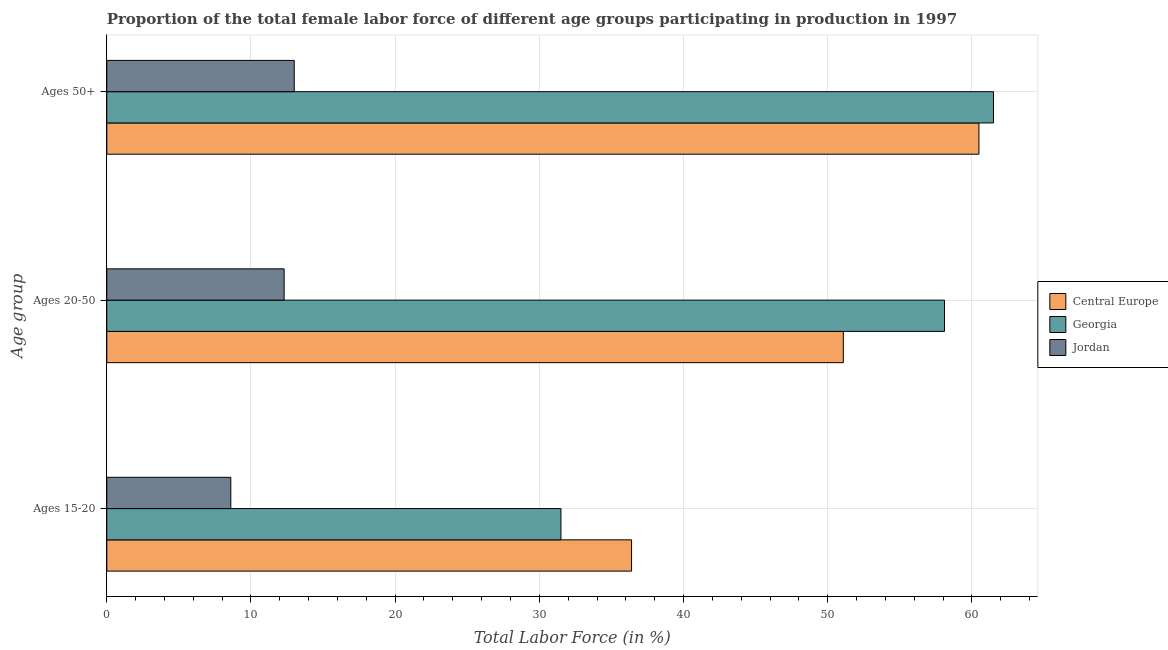How many different coloured bars are there?
Provide a succinct answer. 3. Are the number of bars per tick equal to the number of legend labels?
Make the answer very short. Yes. Are the number of bars on each tick of the Y-axis equal?
Provide a succinct answer. Yes. How many bars are there on the 1st tick from the top?
Your answer should be compact. 3. What is the label of the 2nd group of bars from the top?
Make the answer very short. Ages 20-50. What is the percentage of female labor force within the age group 20-50 in Jordan?
Give a very brief answer. 12.3. Across all countries, what is the maximum percentage of female labor force above age 50?
Ensure brevity in your answer.  61.5. Across all countries, what is the minimum percentage of female labor force within the age group 20-50?
Make the answer very short. 12.3. In which country was the percentage of female labor force within the age group 15-20 maximum?
Provide a short and direct response. Central Europe. In which country was the percentage of female labor force within the age group 15-20 minimum?
Your answer should be very brief. Jordan. What is the total percentage of female labor force above age 50 in the graph?
Your response must be concise. 134.99. What is the difference between the percentage of female labor force within the age group 15-20 in Georgia and that in Jordan?
Your response must be concise. 22.9. What is the difference between the percentage of female labor force within the age group 20-50 in Georgia and the percentage of female labor force within the age group 15-20 in Jordan?
Keep it short and to the point. 49.5. What is the average percentage of female labor force within the age group 20-50 per country?
Provide a succinct answer. 40.5. What is the difference between the percentage of female labor force above age 50 and percentage of female labor force within the age group 20-50 in Jordan?
Provide a short and direct response. 0.7. What is the ratio of the percentage of female labor force within the age group 20-50 in Jordan to that in Georgia?
Your response must be concise. 0.21. Is the percentage of female labor force within the age group 15-20 in Jordan less than that in Georgia?
Your answer should be very brief. Yes. What is the difference between the highest and the second highest percentage of female labor force above age 50?
Provide a succinct answer. 1.01. What is the difference between the highest and the lowest percentage of female labor force within the age group 20-50?
Make the answer very short. 45.8. Is the sum of the percentage of female labor force above age 50 in Jordan and Central Europe greater than the maximum percentage of female labor force within the age group 15-20 across all countries?
Make the answer very short. Yes. What does the 1st bar from the top in Ages 50+ represents?
Make the answer very short. Jordan. What does the 2nd bar from the bottom in Ages 50+ represents?
Provide a short and direct response. Georgia. Is it the case that in every country, the sum of the percentage of female labor force within the age group 15-20 and percentage of female labor force within the age group 20-50 is greater than the percentage of female labor force above age 50?
Provide a short and direct response. Yes. How many bars are there?
Offer a terse response. 9. Does the graph contain any zero values?
Make the answer very short. No. Where does the legend appear in the graph?
Make the answer very short. Center right. How many legend labels are there?
Offer a very short reply. 3. What is the title of the graph?
Make the answer very short. Proportion of the total female labor force of different age groups participating in production in 1997. Does "St. Kitts and Nevis" appear as one of the legend labels in the graph?
Offer a very short reply. No. What is the label or title of the Y-axis?
Ensure brevity in your answer.  Age group. What is the Total Labor Force (in %) in Central Europe in Ages 15-20?
Your answer should be compact. 36.4. What is the Total Labor Force (in %) of Georgia in Ages 15-20?
Your answer should be very brief. 31.5. What is the Total Labor Force (in %) of Jordan in Ages 15-20?
Your response must be concise. 8.6. What is the Total Labor Force (in %) in Central Europe in Ages 20-50?
Offer a terse response. 51.09. What is the Total Labor Force (in %) of Georgia in Ages 20-50?
Your answer should be compact. 58.1. What is the Total Labor Force (in %) of Jordan in Ages 20-50?
Keep it short and to the point. 12.3. What is the Total Labor Force (in %) in Central Europe in Ages 50+?
Provide a short and direct response. 60.49. What is the Total Labor Force (in %) of Georgia in Ages 50+?
Your answer should be very brief. 61.5. Across all Age group, what is the maximum Total Labor Force (in %) of Central Europe?
Ensure brevity in your answer.  60.49. Across all Age group, what is the maximum Total Labor Force (in %) in Georgia?
Offer a very short reply. 61.5. Across all Age group, what is the minimum Total Labor Force (in %) of Central Europe?
Your response must be concise. 36.4. Across all Age group, what is the minimum Total Labor Force (in %) in Georgia?
Offer a terse response. 31.5. Across all Age group, what is the minimum Total Labor Force (in %) of Jordan?
Keep it short and to the point. 8.6. What is the total Total Labor Force (in %) of Central Europe in the graph?
Ensure brevity in your answer.  147.97. What is the total Total Labor Force (in %) in Georgia in the graph?
Keep it short and to the point. 151.1. What is the total Total Labor Force (in %) in Jordan in the graph?
Give a very brief answer. 33.9. What is the difference between the Total Labor Force (in %) in Central Europe in Ages 15-20 and that in Ages 20-50?
Your answer should be very brief. -14.69. What is the difference between the Total Labor Force (in %) of Georgia in Ages 15-20 and that in Ages 20-50?
Offer a terse response. -26.6. What is the difference between the Total Labor Force (in %) of Jordan in Ages 15-20 and that in Ages 20-50?
Provide a succinct answer. -3.7. What is the difference between the Total Labor Force (in %) of Central Europe in Ages 15-20 and that in Ages 50+?
Ensure brevity in your answer.  -24.09. What is the difference between the Total Labor Force (in %) in Georgia in Ages 15-20 and that in Ages 50+?
Your answer should be very brief. -30. What is the difference between the Total Labor Force (in %) in Jordan in Ages 15-20 and that in Ages 50+?
Keep it short and to the point. -4.4. What is the difference between the Total Labor Force (in %) of Central Europe in Ages 20-50 and that in Ages 50+?
Ensure brevity in your answer.  -9.41. What is the difference between the Total Labor Force (in %) in Georgia in Ages 20-50 and that in Ages 50+?
Make the answer very short. -3.4. What is the difference between the Total Labor Force (in %) in Central Europe in Ages 15-20 and the Total Labor Force (in %) in Georgia in Ages 20-50?
Keep it short and to the point. -21.7. What is the difference between the Total Labor Force (in %) in Central Europe in Ages 15-20 and the Total Labor Force (in %) in Jordan in Ages 20-50?
Keep it short and to the point. 24.1. What is the difference between the Total Labor Force (in %) of Georgia in Ages 15-20 and the Total Labor Force (in %) of Jordan in Ages 20-50?
Your answer should be very brief. 19.2. What is the difference between the Total Labor Force (in %) in Central Europe in Ages 15-20 and the Total Labor Force (in %) in Georgia in Ages 50+?
Offer a terse response. -25.1. What is the difference between the Total Labor Force (in %) of Central Europe in Ages 15-20 and the Total Labor Force (in %) of Jordan in Ages 50+?
Make the answer very short. 23.4. What is the difference between the Total Labor Force (in %) of Central Europe in Ages 20-50 and the Total Labor Force (in %) of Georgia in Ages 50+?
Keep it short and to the point. -10.41. What is the difference between the Total Labor Force (in %) in Central Europe in Ages 20-50 and the Total Labor Force (in %) in Jordan in Ages 50+?
Offer a very short reply. 38.09. What is the difference between the Total Labor Force (in %) of Georgia in Ages 20-50 and the Total Labor Force (in %) of Jordan in Ages 50+?
Your answer should be very brief. 45.1. What is the average Total Labor Force (in %) of Central Europe per Age group?
Offer a terse response. 49.32. What is the average Total Labor Force (in %) of Georgia per Age group?
Ensure brevity in your answer.  50.37. What is the average Total Labor Force (in %) in Jordan per Age group?
Provide a succinct answer. 11.3. What is the difference between the Total Labor Force (in %) in Central Europe and Total Labor Force (in %) in Georgia in Ages 15-20?
Make the answer very short. 4.9. What is the difference between the Total Labor Force (in %) of Central Europe and Total Labor Force (in %) of Jordan in Ages 15-20?
Your response must be concise. 27.8. What is the difference between the Total Labor Force (in %) in Georgia and Total Labor Force (in %) in Jordan in Ages 15-20?
Your answer should be very brief. 22.9. What is the difference between the Total Labor Force (in %) in Central Europe and Total Labor Force (in %) in Georgia in Ages 20-50?
Your answer should be compact. -7.01. What is the difference between the Total Labor Force (in %) in Central Europe and Total Labor Force (in %) in Jordan in Ages 20-50?
Offer a very short reply. 38.79. What is the difference between the Total Labor Force (in %) in Georgia and Total Labor Force (in %) in Jordan in Ages 20-50?
Your answer should be compact. 45.8. What is the difference between the Total Labor Force (in %) of Central Europe and Total Labor Force (in %) of Georgia in Ages 50+?
Offer a terse response. -1.01. What is the difference between the Total Labor Force (in %) in Central Europe and Total Labor Force (in %) in Jordan in Ages 50+?
Provide a succinct answer. 47.49. What is the difference between the Total Labor Force (in %) of Georgia and Total Labor Force (in %) of Jordan in Ages 50+?
Give a very brief answer. 48.5. What is the ratio of the Total Labor Force (in %) of Central Europe in Ages 15-20 to that in Ages 20-50?
Make the answer very short. 0.71. What is the ratio of the Total Labor Force (in %) in Georgia in Ages 15-20 to that in Ages 20-50?
Ensure brevity in your answer.  0.54. What is the ratio of the Total Labor Force (in %) of Jordan in Ages 15-20 to that in Ages 20-50?
Make the answer very short. 0.7. What is the ratio of the Total Labor Force (in %) in Central Europe in Ages 15-20 to that in Ages 50+?
Your answer should be very brief. 0.6. What is the ratio of the Total Labor Force (in %) in Georgia in Ages 15-20 to that in Ages 50+?
Offer a very short reply. 0.51. What is the ratio of the Total Labor Force (in %) of Jordan in Ages 15-20 to that in Ages 50+?
Provide a succinct answer. 0.66. What is the ratio of the Total Labor Force (in %) in Central Europe in Ages 20-50 to that in Ages 50+?
Your answer should be compact. 0.84. What is the ratio of the Total Labor Force (in %) of Georgia in Ages 20-50 to that in Ages 50+?
Give a very brief answer. 0.94. What is the ratio of the Total Labor Force (in %) in Jordan in Ages 20-50 to that in Ages 50+?
Give a very brief answer. 0.95. What is the difference between the highest and the second highest Total Labor Force (in %) of Central Europe?
Ensure brevity in your answer.  9.41. What is the difference between the highest and the lowest Total Labor Force (in %) of Central Europe?
Provide a short and direct response. 24.09. 